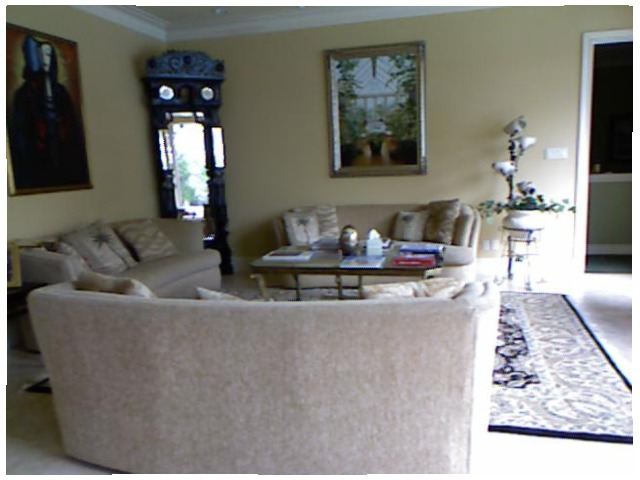<image>
Is the picture above the sofa? No. The picture is not positioned above the sofa. The vertical arrangement shows a different relationship. Is there a wall behind the painting? Yes. From this viewpoint, the wall is positioned behind the painting, with the painting partially or fully occluding the wall. 